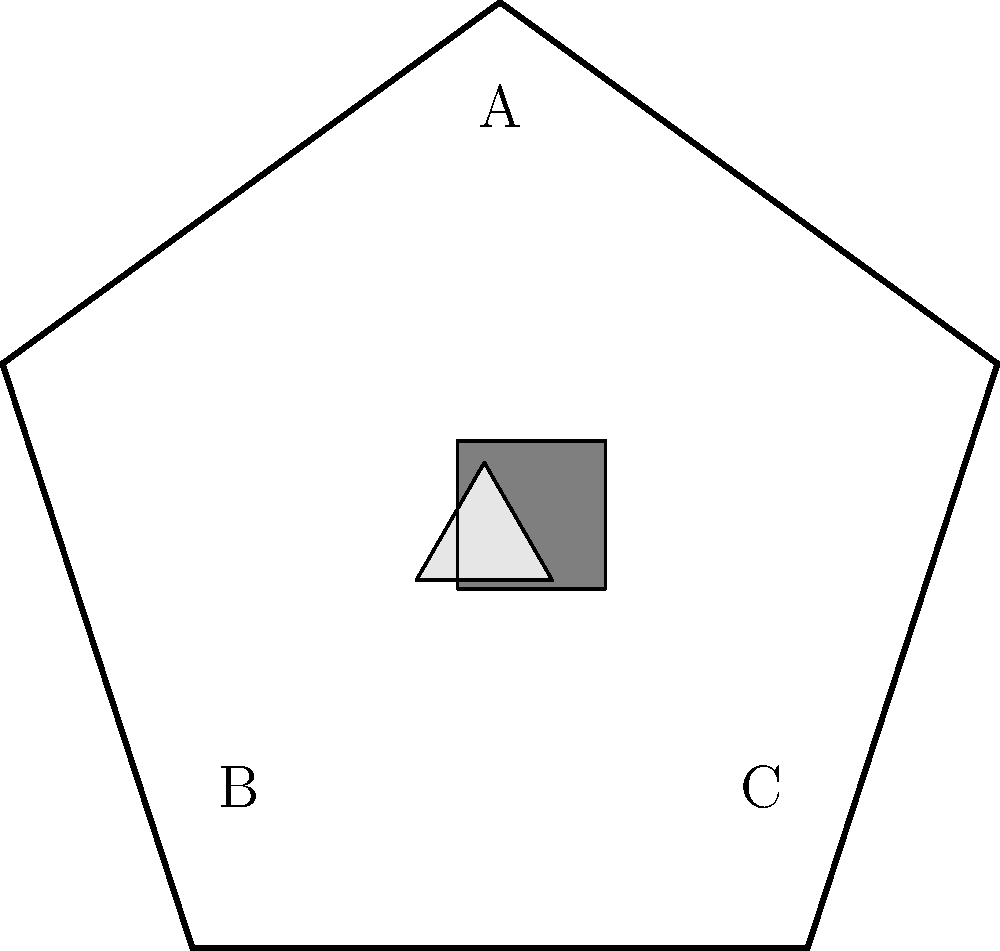In the geometric representation of international borders shown above, where country A is represented by the pentagon and countries B and C are represented by the enclaves within it, what is the minimum number of border crossings required to travel from B to C while passing through A? To determine the minimum number of border crossings required to travel from B to C while passing through A, we need to analyze the geometric representation:

1. Country B is represented by the triangular enclave (lightgray) within the pentagon (country A).
2. Country C is represented by the square enclave (gray) within the pentagon (country A).
3. To travel from B to C, we must:
   a. Cross from B into A (1st border crossing)
   b. Travel through A
   c. Cross from A into C (2nd border crossing)

4. There is no direct path between B and C without passing through A, as they are separate enclaves within A.

5. The minimum number of border crossings is achieved by crossing only these two necessary borders: B-A and A-C.

Therefore, the minimum number of border crossings required is 2.
Answer: 2 